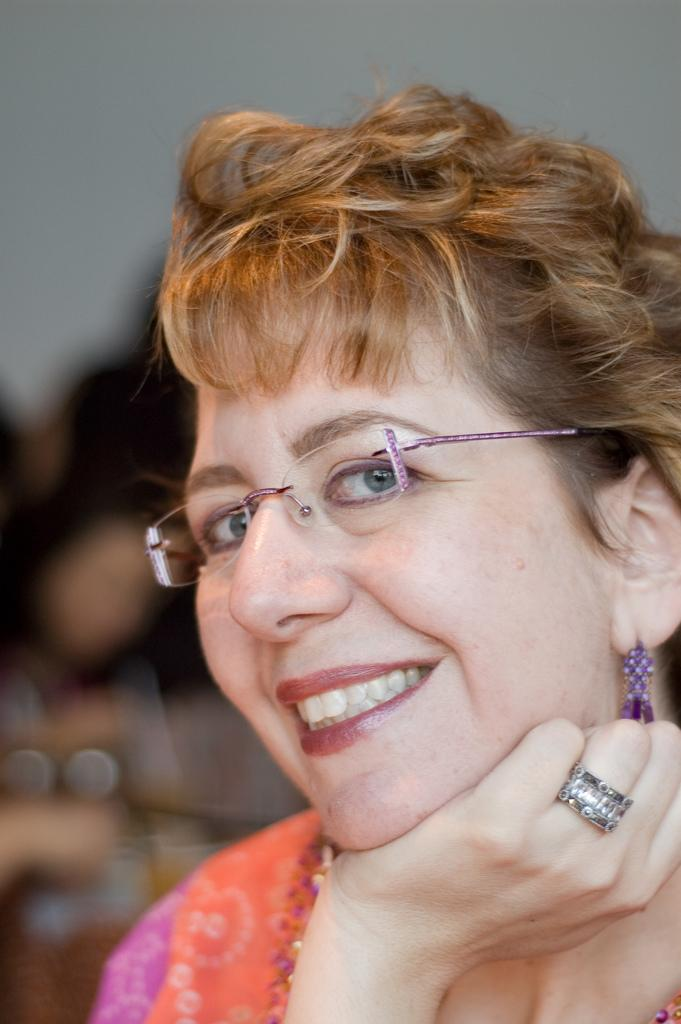What is present in the image? There is a woman in the image. What is the woman doing in the image? The woman is smiling in the image. What accessory is the woman wearing in the image? The woman is wearing spectacles in the image. What type of dinosaur can be seen in the image? There is no dinosaur present in the image. What shape is the horse in the image? There is no horse present in the image. 